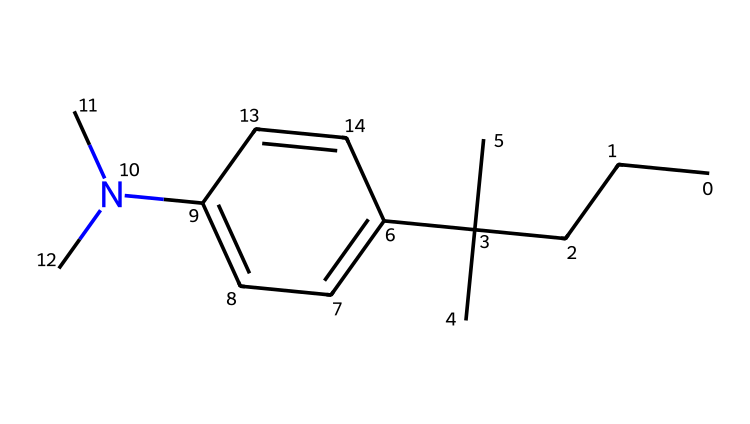What is the molecular formula of this compound? To determine the molecular formula, count the number of carbon, hydrogen, and nitrogen atoms present in the SMILES representation. Here, there are 15 carbon atoms, 23 hydrogen atoms, and 1 nitrogen atom. Thus, the formula is C15H23N.
Answer: C15H23N How many rings are present in the structure? By examining the SMILES string, it is evident that the only ring present is the aromatic benzene ring (indicated by 'c'), which consists of 6 carbon atoms. No other rings exist in the structure.
Answer: 1 What type of functional group is indicated by the amine in this compound? The presence of the nitrogen atom (N) bonded to carbon indicates that this is a secondary amine, as it is attached to two carbon groups.
Answer: secondary amine How many isopropyl groups are there in the structure? The chemical structure features two isopropyl groups, which can be identified as the C(C)(C) arrangement showing branching, indicating the presence of isopropyl functional groups.
Answer: 2 What information does the presence of nitrogen provide about the chemical's properties? The nitrogen in the structure suggests that it may enhance the octane rating of the fuel, thus improving combustion efficiency and reducing knocking in vintage automobile engines.
Answer: enhances octane rating Which parts of the molecule are responsible for its hydrophobic properties? The long carbon chains and aliphatic groups (the CCCCC part) contribute to the hydrophobic properties of the compound, minimizing its interaction with water.
Answer: long carbon chains 